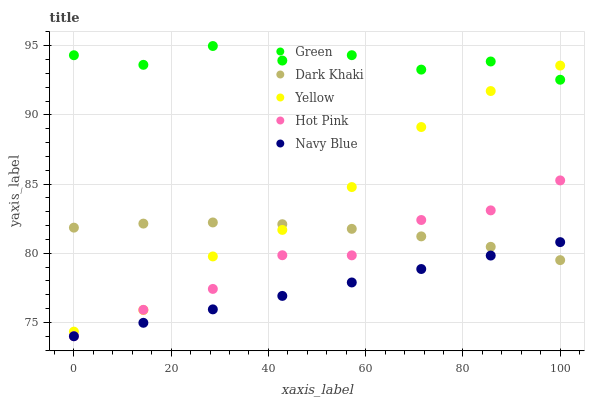Does Navy Blue have the minimum area under the curve?
Answer yes or no. Yes. Does Green have the maximum area under the curve?
Answer yes or no. Yes. Does Hot Pink have the minimum area under the curve?
Answer yes or no. No. Does Hot Pink have the maximum area under the curve?
Answer yes or no. No. Is Navy Blue the smoothest?
Answer yes or no. Yes. Is Green the roughest?
Answer yes or no. Yes. Is Hot Pink the smoothest?
Answer yes or no. No. Is Hot Pink the roughest?
Answer yes or no. No. Does Navy Blue have the lowest value?
Answer yes or no. Yes. Does Green have the lowest value?
Answer yes or no. No. Does Green have the highest value?
Answer yes or no. Yes. Does Hot Pink have the highest value?
Answer yes or no. No. Is Hot Pink less than Green?
Answer yes or no. Yes. Is Green greater than Dark Khaki?
Answer yes or no. Yes. Does Hot Pink intersect Dark Khaki?
Answer yes or no. Yes. Is Hot Pink less than Dark Khaki?
Answer yes or no. No. Is Hot Pink greater than Dark Khaki?
Answer yes or no. No. Does Hot Pink intersect Green?
Answer yes or no. No. 